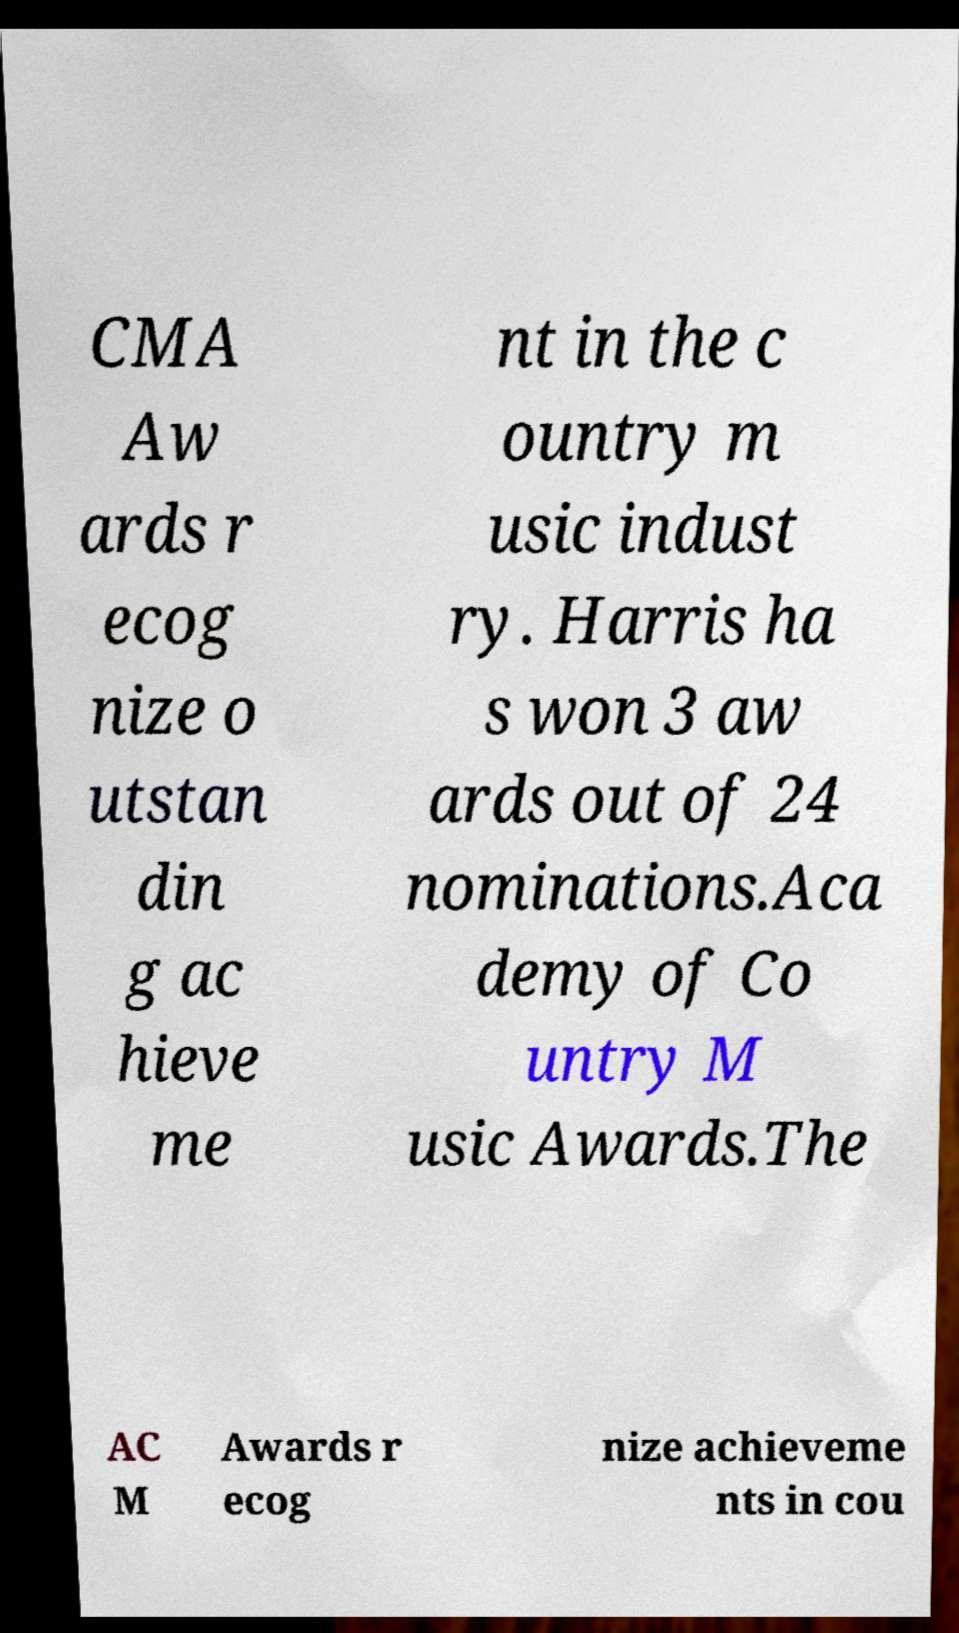Can you read and provide the text displayed in the image?This photo seems to have some interesting text. Can you extract and type it out for me? CMA Aw ards r ecog nize o utstan din g ac hieve me nt in the c ountry m usic indust ry. Harris ha s won 3 aw ards out of 24 nominations.Aca demy of Co untry M usic Awards.The AC M Awards r ecog nize achieveme nts in cou 